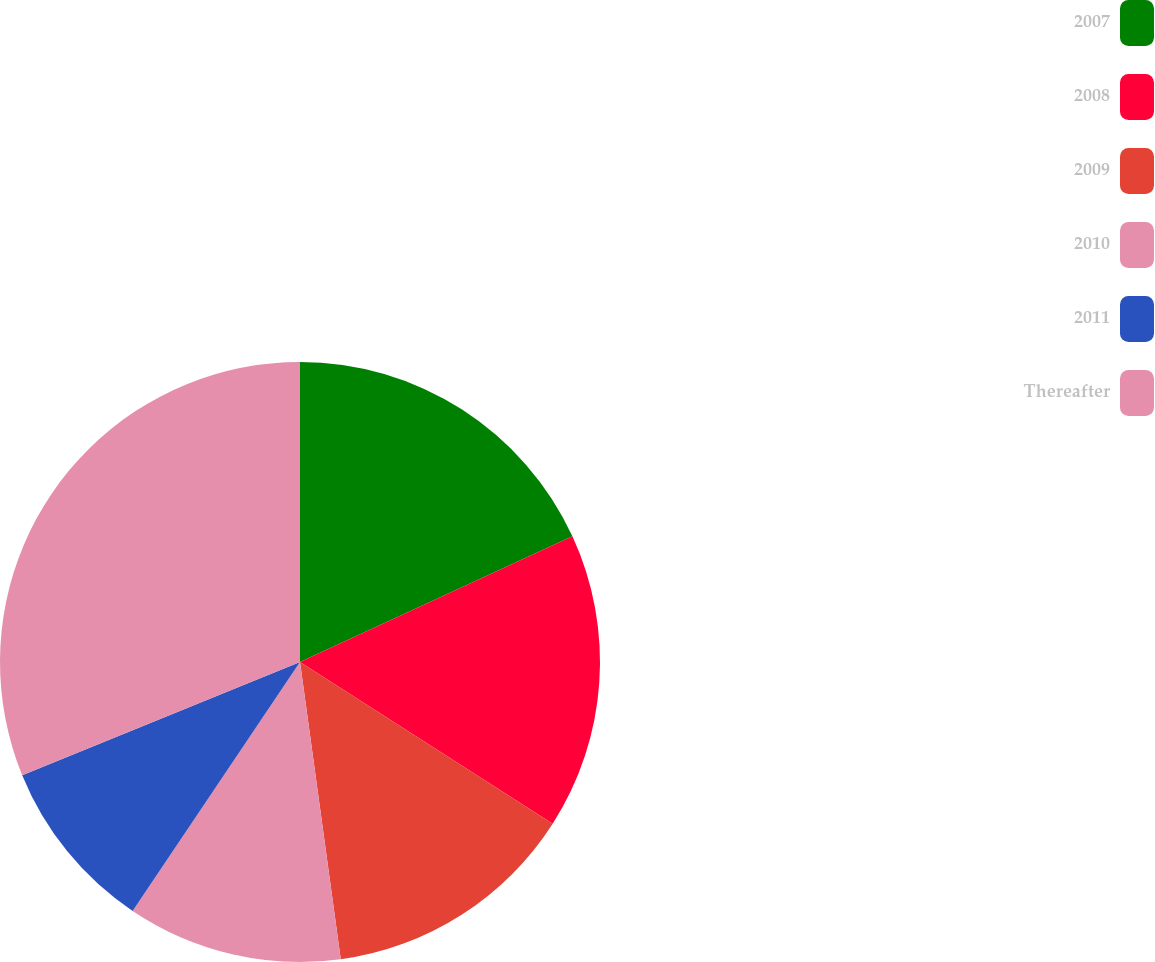Convert chart. <chart><loc_0><loc_0><loc_500><loc_500><pie_chart><fcel>2007<fcel>2008<fcel>2009<fcel>2010<fcel>2011<fcel>Thereafter<nl><fcel>18.12%<fcel>15.94%<fcel>13.77%<fcel>11.59%<fcel>9.42%<fcel>31.16%<nl></chart> 